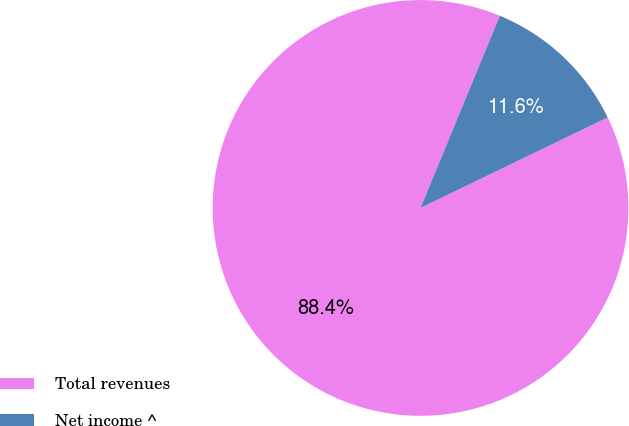Convert chart. <chart><loc_0><loc_0><loc_500><loc_500><pie_chart><fcel>Total revenues<fcel>Net income ^<nl><fcel>88.4%<fcel>11.6%<nl></chart> 